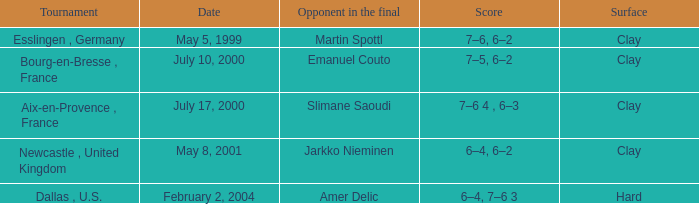What is the Opponent in the final of the game on february 2, 2004? Amer Delic. 